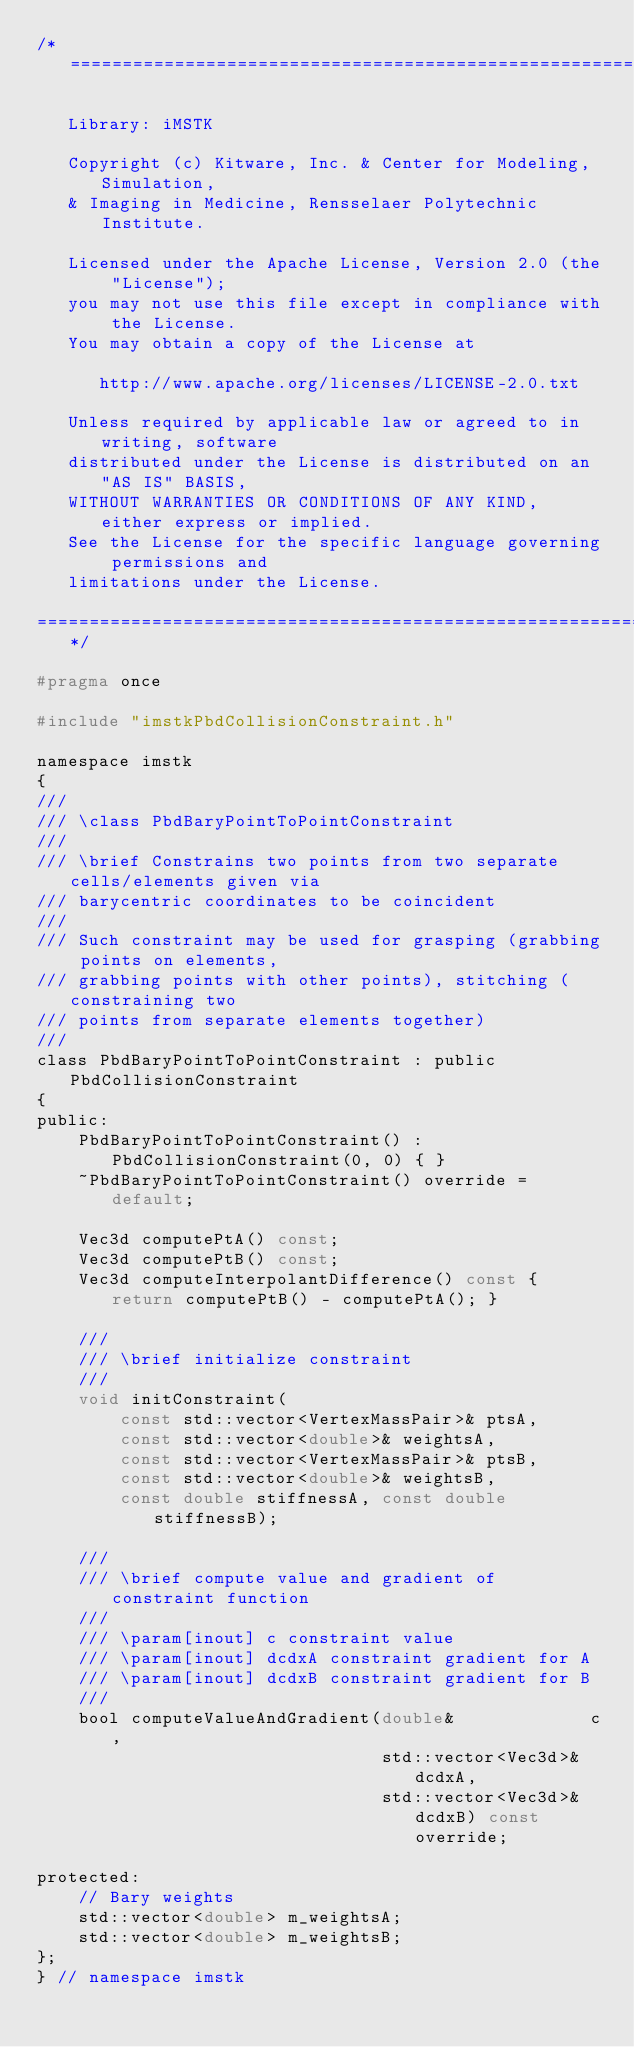Convert code to text. <code><loc_0><loc_0><loc_500><loc_500><_C_>/*=========================================================================

   Library: iMSTK

   Copyright (c) Kitware, Inc. & Center for Modeling, Simulation,
   & Imaging in Medicine, Rensselaer Polytechnic Institute.

   Licensed under the Apache License, Version 2.0 (the "License");
   you may not use this file except in compliance with the License.
   You may obtain a copy of the License at

      http://www.apache.org/licenses/LICENSE-2.0.txt

   Unless required by applicable law or agreed to in writing, software
   distributed under the License is distributed on an "AS IS" BASIS,
   WITHOUT WARRANTIES OR CONDITIONS OF ANY KIND, either express or implied.
   See the License for the specific language governing permissions and
   limitations under the License.

=========================================================================*/

#pragma once

#include "imstkPbdCollisionConstraint.h"

namespace imstk
{
///
/// \class PbdBaryPointToPointConstraint
///
/// \brief Constrains two points from two separate cells/elements given via
/// barycentric coordinates to be coincident
///
/// Such constraint may be used for grasping (grabbing points on elements,
/// grabbing points with other points), stitching (constraining two
/// points from separate elements together)
///
class PbdBaryPointToPointConstraint : public PbdCollisionConstraint
{
public:
    PbdBaryPointToPointConstraint() : PbdCollisionConstraint(0, 0) { }
    ~PbdBaryPointToPointConstraint() override = default;

    Vec3d computePtA() const;
    Vec3d computePtB() const;
    Vec3d computeInterpolantDifference() const { return computePtB() - computePtA(); }

    ///
    /// \brief initialize constraint
    ///
    void initConstraint(
        const std::vector<VertexMassPair>& ptsA,
        const std::vector<double>& weightsA,
        const std::vector<VertexMassPair>& ptsB,
        const std::vector<double>& weightsB,
        const double stiffnessA, const double stiffnessB);

    ///
    /// \brief compute value and gradient of constraint function
    ///
    /// \param[inout] c constraint value
    /// \param[inout] dcdxA constraint gradient for A
    /// \param[inout] dcdxB constraint gradient for B
    ///
    bool computeValueAndGradient(double&             c,
                                 std::vector<Vec3d>& dcdxA,
                                 std::vector<Vec3d>& dcdxB) const override;

protected:
    // Bary weights
    std::vector<double> m_weightsA;
    std::vector<double> m_weightsB;
};
} // namespace imstk</code> 